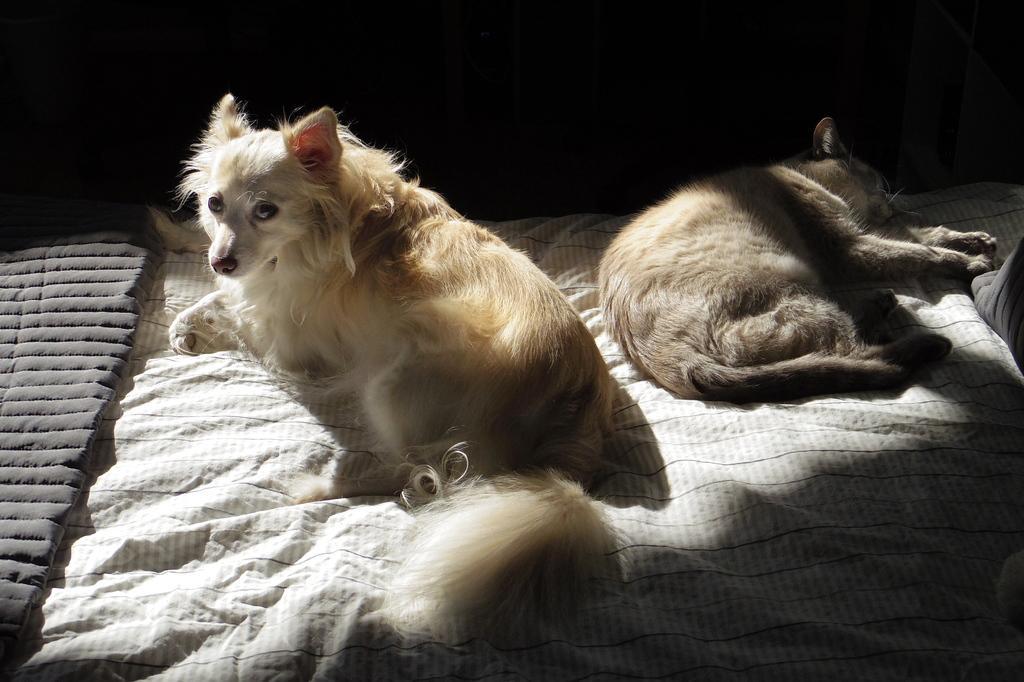Could you give a brief overview of what you see in this image? In this image there is a dog sitting on the bed. Behind the dog there is another dog which is sleeping on the bed. At the bottom there is blanket. 